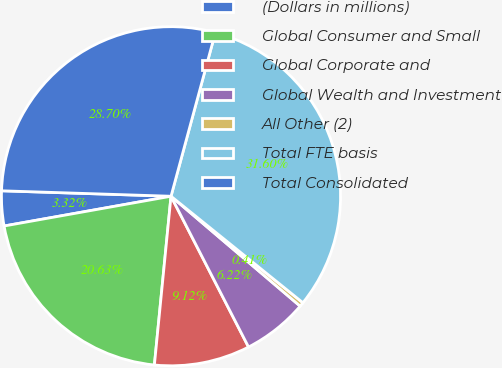<chart> <loc_0><loc_0><loc_500><loc_500><pie_chart><fcel>(Dollars in millions)<fcel>Global Consumer and Small<fcel>Global Corporate and<fcel>Global Wealth and Investment<fcel>All Other (2)<fcel>Total FTE basis<fcel>Total Consolidated<nl><fcel>3.32%<fcel>20.63%<fcel>9.12%<fcel>6.22%<fcel>0.41%<fcel>31.6%<fcel>28.7%<nl></chart> 